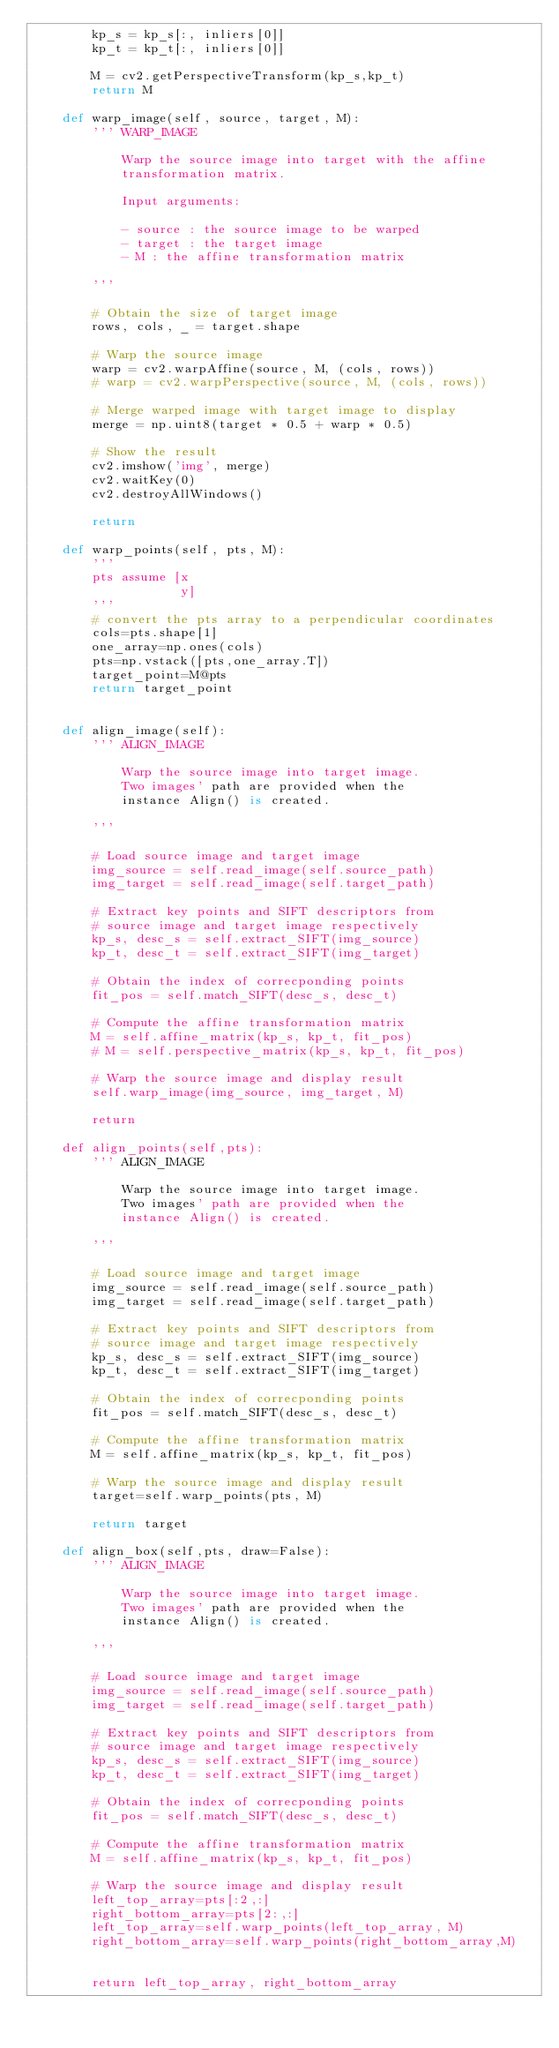Convert code to text. <code><loc_0><loc_0><loc_500><loc_500><_Python_>        kp_s = kp_s[:, inliers[0]]
        kp_t = kp_t[:, inliers[0]]

        M = cv2.getPerspectiveTransform(kp_s,kp_t)
        return M

    def warp_image(self, source, target, M):
        ''' WARP_IMAGE

            Warp the source image into target with the affine
            transformation matrix.

            Input arguments:

            - source : the source image to be warped
            - target : the target image
            - M : the affine transformation matrix

        '''

        # Obtain the size of target image
        rows, cols, _ = target.shape

        # Warp the source image
        warp = cv2.warpAffine(source, M, (cols, rows))
        # warp = cv2.warpPerspective(source, M, (cols, rows))

        # Merge warped image with target image to display
        merge = np.uint8(target * 0.5 + warp * 0.5)

        # Show the result
        cv2.imshow('img', merge)
        cv2.waitKey(0)
        cv2.destroyAllWindows()

        return

    def warp_points(self, pts, M):
        '''
        pts assume [x
                    y]
        '''
        # convert the pts array to a perpendicular coordinates
        cols=pts.shape[1]
        one_array=np.ones(cols)
        pts=np.vstack([pts,one_array.T])
        target_point=M@pts
        return target_point


    def align_image(self):
        ''' ALIGN_IMAGE

            Warp the source image into target image.
            Two images' path are provided when the
            instance Align() is created.

        '''

        # Load source image and target image
        img_source = self.read_image(self.source_path)
        img_target = self.read_image(self.target_path)

        # Extract key points and SIFT descriptors from
        # source image and target image respectively
        kp_s, desc_s = self.extract_SIFT(img_source)
        kp_t, desc_t = self.extract_SIFT(img_target)

        # Obtain the index of correcponding points
        fit_pos = self.match_SIFT(desc_s, desc_t)

        # Compute the affine transformation matrix
        M = self.affine_matrix(kp_s, kp_t, fit_pos)
        # M = self.perspective_matrix(kp_s, kp_t, fit_pos)

        # Warp the source image and display result
        self.warp_image(img_source, img_target, M)

        return

    def align_points(self,pts):
        ''' ALIGN_IMAGE

            Warp the source image into target image.
            Two images' path are provided when the
            instance Align() is created.

        '''

        # Load source image and target image
        img_source = self.read_image(self.source_path)
        img_target = self.read_image(self.target_path)

        # Extract key points and SIFT descriptors from
        # source image and target image respectively
        kp_s, desc_s = self.extract_SIFT(img_source)
        kp_t, desc_t = self.extract_SIFT(img_target)

        # Obtain the index of correcponding points
        fit_pos = self.match_SIFT(desc_s, desc_t)

        # Compute the affine transformation matrix
        M = self.affine_matrix(kp_s, kp_t, fit_pos)

        # Warp the source image and display result
        target=self.warp_points(pts, M)

        return target

    def align_box(self,pts, draw=False):
        ''' ALIGN_IMAGE

            Warp the source image into target image.
            Two images' path are provided when the
            instance Align() is created.

        '''

        # Load source image and target image
        img_source = self.read_image(self.source_path)
        img_target = self.read_image(self.target_path)

        # Extract key points and SIFT descriptors from
        # source image and target image respectively
        kp_s, desc_s = self.extract_SIFT(img_source)
        kp_t, desc_t = self.extract_SIFT(img_target)

        # Obtain the index of correcponding points
        fit_pos = self.match_SIFT(desc_s, desc_t)

        # Compute the affine transformation matrix
        M = self.affine_matrix(kp_s, kp_t, fit_pos)

        # Warp the source image and display result
        left_top_array=pts[:2,:]
        right_bottom_array=pts[2:,:]
        left_top_array=self.warp_points(left_top_array, M)
        right_bottom_array=self.warp_points(right_bottom_array,M)

        
        return left_top_array, right_bottom_array
</code> 